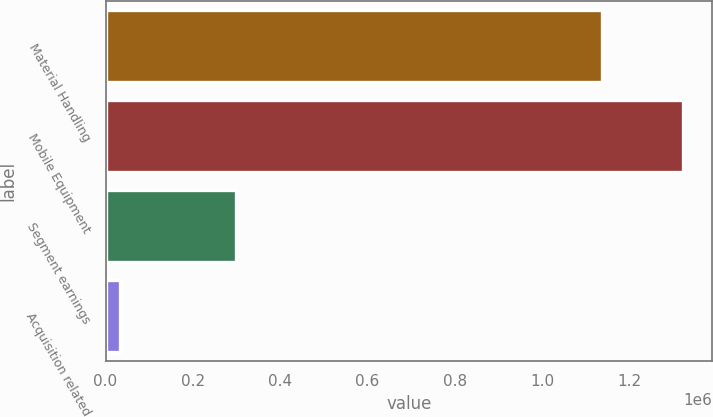Convert chart to OTSL. <chart><loc_0><loc_0><loc_500><loc_500><bar_chart><fcel>Material Handling<fcel>Mobile Equipment<fcel>Segment earnings<fcel>Acquisition related<nl><fcel>1.13687e+06<fcel>1.32342e+06<fcel>299740<fcel>32283<nl></chart> 